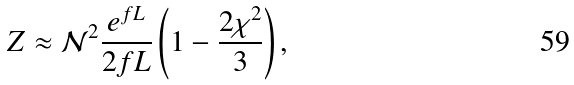Convert formula to latex. <formula><loc_0><loc_0><loc_500><loc_500>Z \approx \mathcal { N } ^ { 2 } \frac { e ^ { f L } } { 2 f L } \left ( 1 - \frac { 2 \chi ^ { 2 } } { 3 } \right ) ,</formula> 